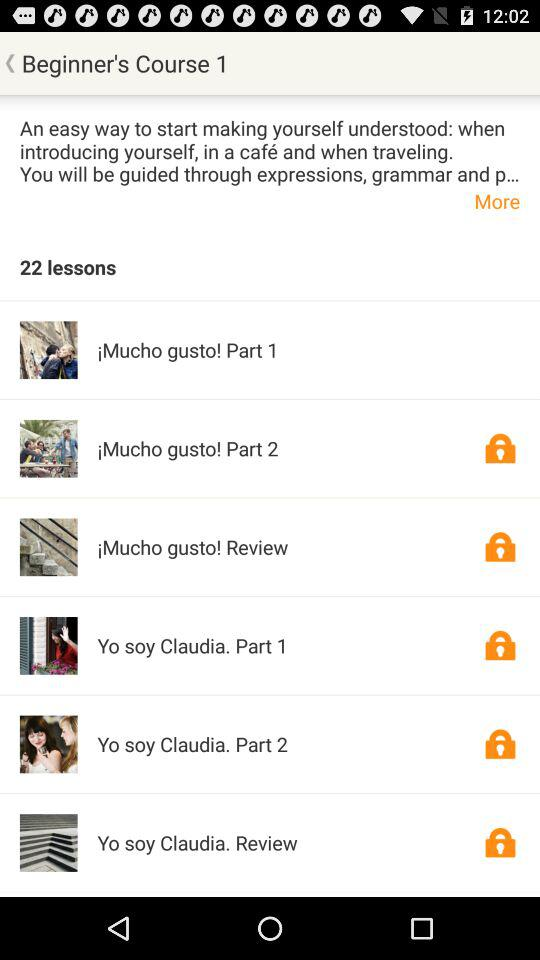How many lessons are there? There are 22 lessons. 